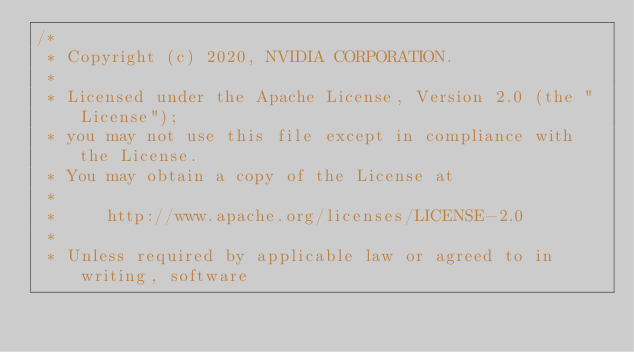<code> <loc_0><loc_0><loc_500><loc_500><_Cuda_>/*
 * Copyright (c) 2020, NVIDIA CORPORATION.
 *
 * Licensed under the Apache License, Version 2.0 (the "License");
 * you may not use this file except in compliance with the License.
 * You may obtain a copy of the License at
 *
 *     http://www.apache.org/licenses/LICENSE-2.0
 *
 * Unless required by applicable law or agreed to in writing, software</code> 